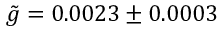Convert formula to latex. <formula><loc_0><loc_0><loc_500><loc_500>\tilde { g } = 0 . 0 0 2 3 \pm 0 . 0 0 0 3</formula> 